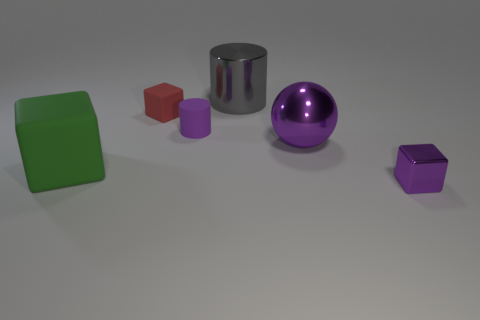Add 4 big blue matte blocks. How many objects exist? 10 Subtract all cylinders. How many objects are left? 4 Add 3 small matte blocks. How many small matte blocks are left? 4 Add 1 big gray cylinders. How many big gray cylinders exist? 2 Subtract 0 brown cylinders. How many objects are left? 6 Subtract all metallic cubes. Subtract all red things. How many objects are left? 4 